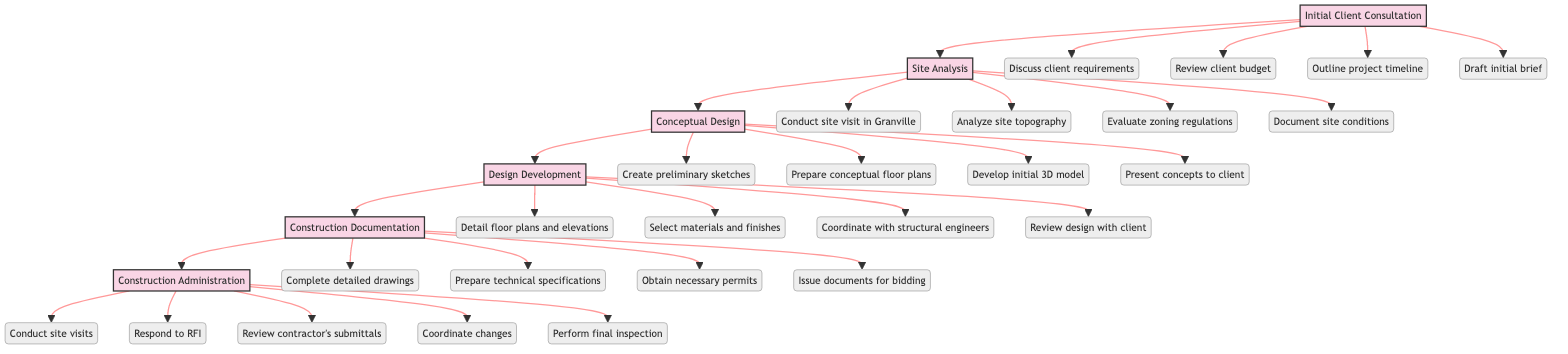What is the first stage of the architectural design process? The diagram shows that the first stage is "Initial Client Consultation," as it is the starting point of the flowchart before any other stages.
Answer: Initial Client Consultation How many stages are there in total in the diagram? By counting the stages in the flowchart, there are six distinct stages listed, from initial consultation to construction administration.
Answer: Six What is the last step in the construction administration stage? The final step in the "Construction Administration" stage is "Perform final inspection and project handover," which is positioned at the end of that stage.
Answer: Perform final inspection and project handover What comes after the conceptual design stage? The diagram indicates that the stage following "Conceptual Design" is "Design Development," which is directly connected in the flow of the process.
Answer: Design Development Which stage involves site visits for progress inspections? "Construction Administration" includes the step of "Conduct site visits for progress inspections," specifically highlighting activities to ensure compliance during construction.
Answer: Construction Administration What is a key activity in the initial client consultation? One of the key activities is "Discuss client requirements," which is explicitly mentioned as a step in the "Initial Client Consultation" stage.
Answer: Discuss client requirements How many steps are there in total for the site analysis stage? The diagram lists four steps under "Site Analysis," each detailing aspects to be evaluated during this stage of the design process.
Answer: Four What is a significant task during the design development stage? A significant task is "Select materials and finishes," which is highlighted as an important step in shaping the final design outcomes.
Answer: Select materials and finishes Which stage requires obtaining necessary permits from Granville authorities? The task "Obtain necessary permits from Granville authorities" is specifically part of the "Construction Documentation" stage, showing it's essential for compliance before construction begins.
Answer: Construction Documentation 